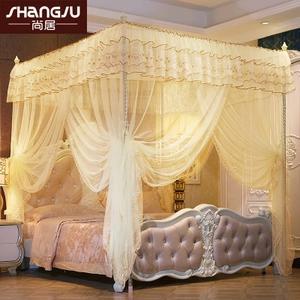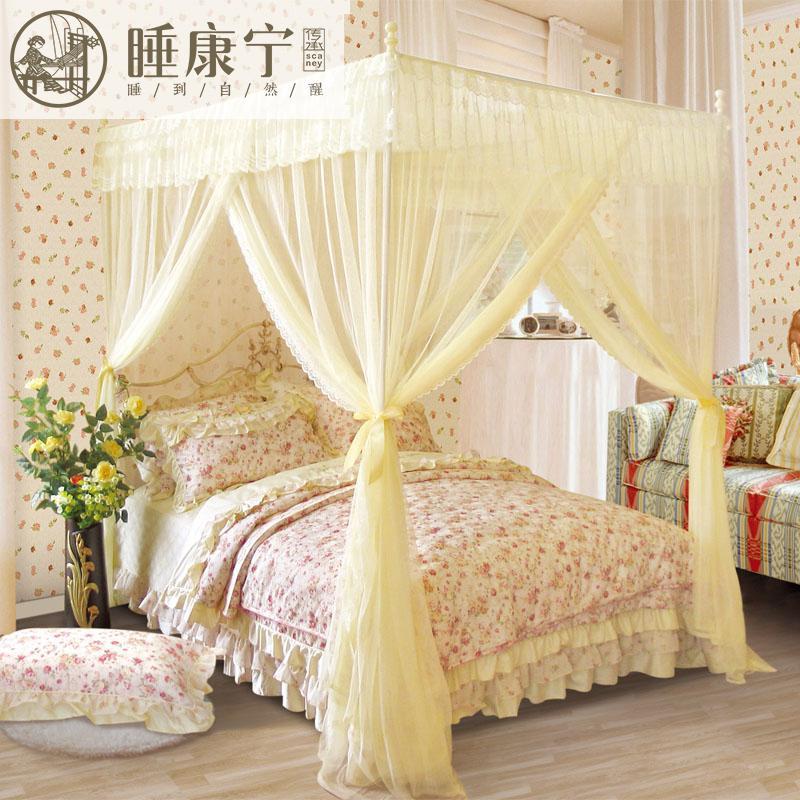The first image is the image on the left, the second image is the image on the right. Assess this claim about the two images: "In each image, a four poster bed is covered with sheer draperies gathered at each post, with a top ruffle and visible knobs at the top of posts.". Correct or not? Answer yes or no. Yes. 